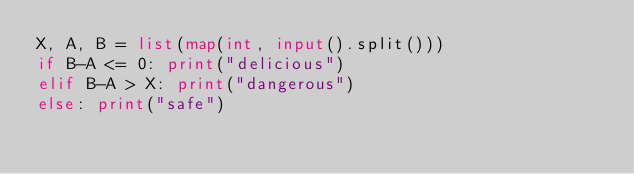<code> <loc_0><loc_0><loc_500><loc_500><_Python_>X, A, B = list(map(int, input().split()))
if B-A <= 0: print("delicious")
elif B-A > X: print("dangerous")
else: print("safe")</code> 